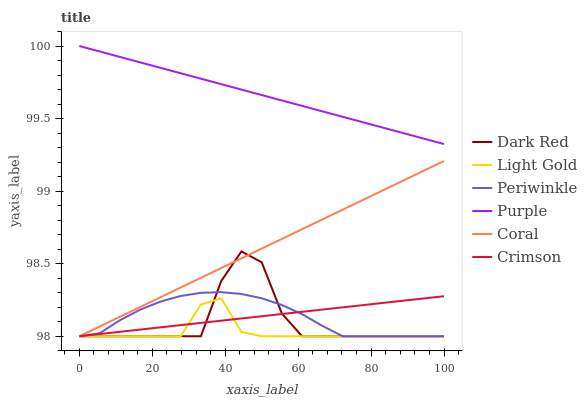Does Dark Red have the minimum area under the curve?
Answer yes or no. No. Does Dark Red have the maximum area under the curve?
Answer yes or no. No. Is Dark Red the smoothest?
Answer yes or no. No. Is Coral the roughest?
Answer yes or no. No. Does Dark Red have the highest value?
Answer yes or no. No. Is Crimson less than Purple?
Answer yes or no. Yes. Is Purple greater than Periwinkle?
Answer yes or no. Yes. Does Crimson intersect Purple?
Answer yes or no. No. 